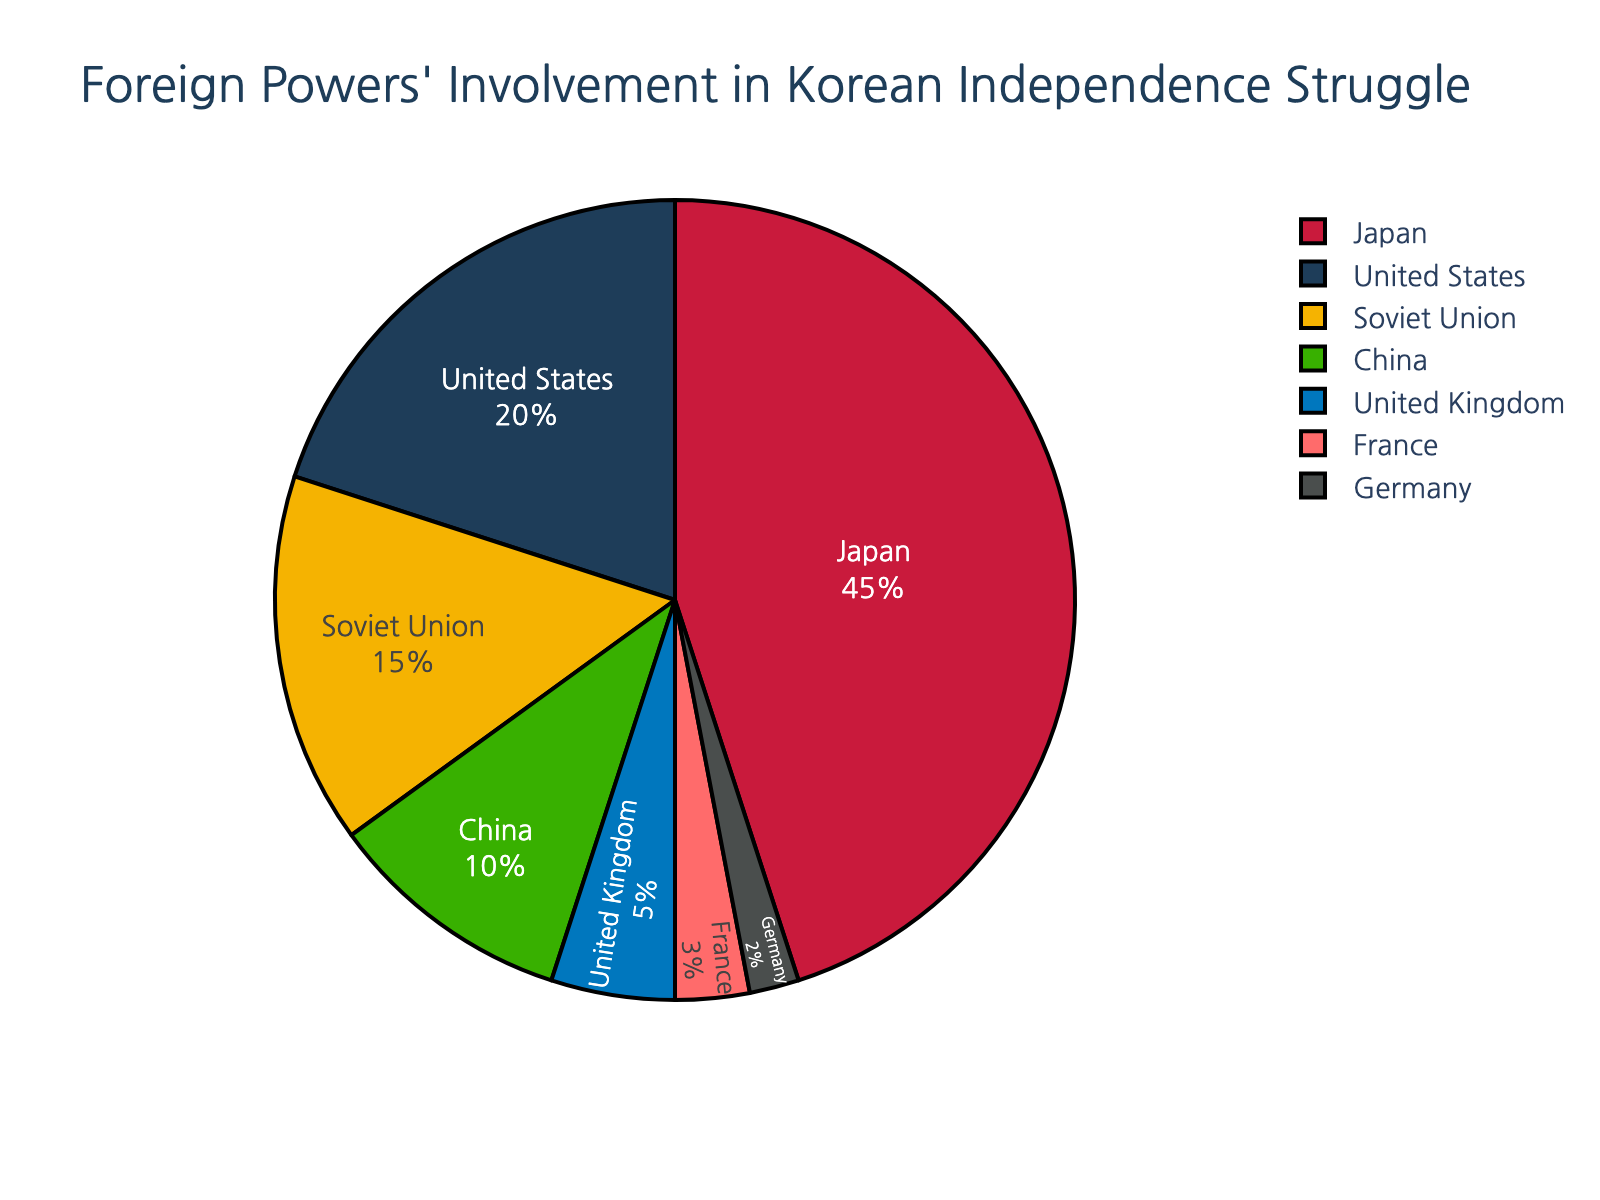Which country's involvement in the struggle for Korean independence is represented by the largest segment? The figure's largest segment represents Japan, showcasing its 45% involvement, the highest among the represented countries.
Answer: Japan What is the combined involvement percentage of the United States and China? Adding the involvement percentages of the United States (20%) and China (10%), we get: 20 + 10 = 30.
Answer: 30% How does the Soviet Union's involvement compare to that of France? The Soviet Union's segment is larger than France's; 15% versus 3%, meaning Soviet Union's involvement is greater.
Answer: Soviet Union's involvement is greater Which country has the smallest involvement percentage? The figure indicates that Germany has the smallest involvement with a segment of 2%.
Answer: Germany How much larger is Japan's involvement compared to that of the United Kingdom? Subtracting the United Kingdom's percentage (5%) from Japan's (45%), gives 45 - 5 = 40.
Answer: 40% Which color represents China's involvement, and what is its percentage? China's segment is represented in green in the figure, which corresponds to a 10% involvement percentage.
Answer: Green, 10% If you combine the involvement of all countries except Japan, what percentage do you get? Summing up the involvement of the United States (20%), Soviet Union (15%), China (10%), United Kingdom (5%), France (3%), and Germany (2%) gives 20 + 15 + 10 + 5 + 3 + 2 = 55%.
Answer: 55% Which two countries have involvement percentages that sum up to the same value as Japan's involvement? The United States (20%) and the Soviet Union (15%) together sum to 35%, so adding China with 10% (20 + 15 + 10) gives 45%, matching Japan's involvement.
Answer: United States, Soviet Union, and China What is the difference in involvement percentage between the United States and France? Subtracting France's percentage (3%) from the United States' (20%) results in 20 - 3 = 17.
Answer: 17% How much greater is the involvement of the United Kingdom compared to Germany? Subtracting Germany's percentage (2%) from the United Kingdom's (5%) yields 5 - 2 = 3.
Answer: 3% 